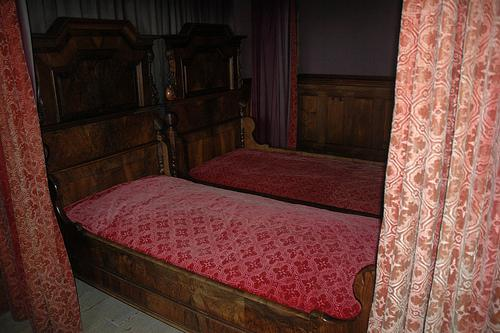Question: what is this a picture of?
Choices:
A. Sofa.
B. Chair.
C. Bed.
D. Loveseat.
Answer with the letter. Answer: C Question: who is on the bed?
Choices:
A. Baby.
B. Woman.
C. Ghost.
D. Nobody.
Answer with the letter. Answer: D Question: where was the picture taken?
Choices:
A. Bedroom.
B. Den.
C. Kitchen.
D. Bathroom.
Answer with the letter. Answer: A 